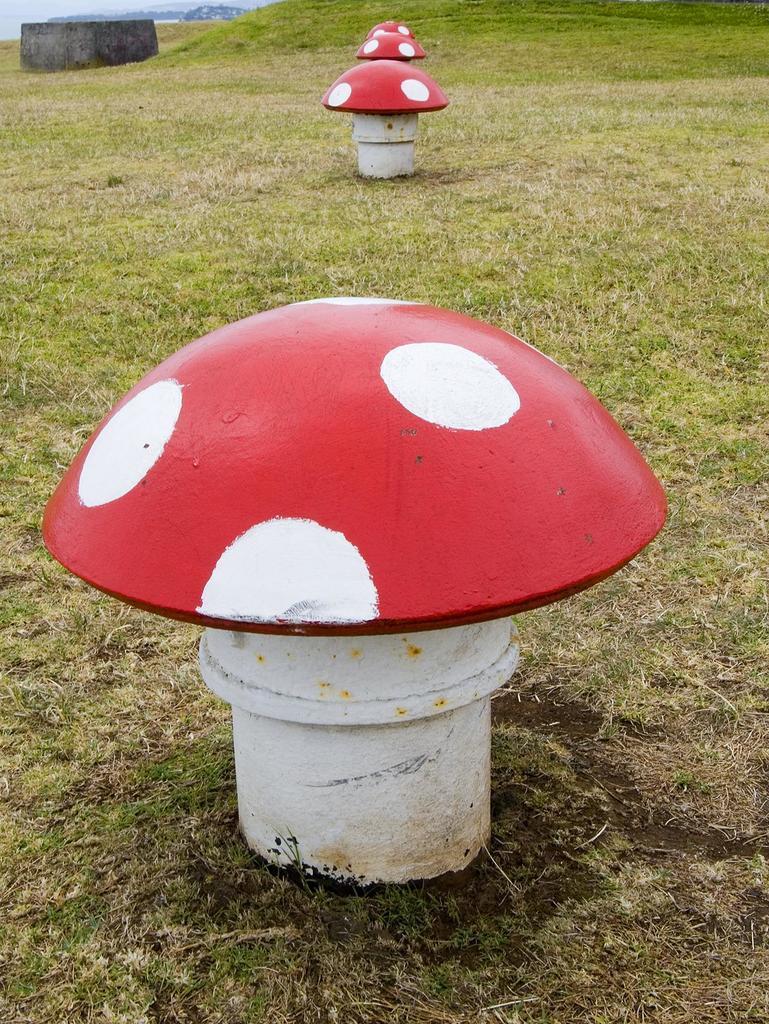In one or two sentences, can you explain what this image depicts? In this picture, we see four small poles in red and white color. They look like mushrooms. At the bottom of the picture, we see grass. In the left top of the picture, we see something in black color which looks like a box. In the background, there are hills. 